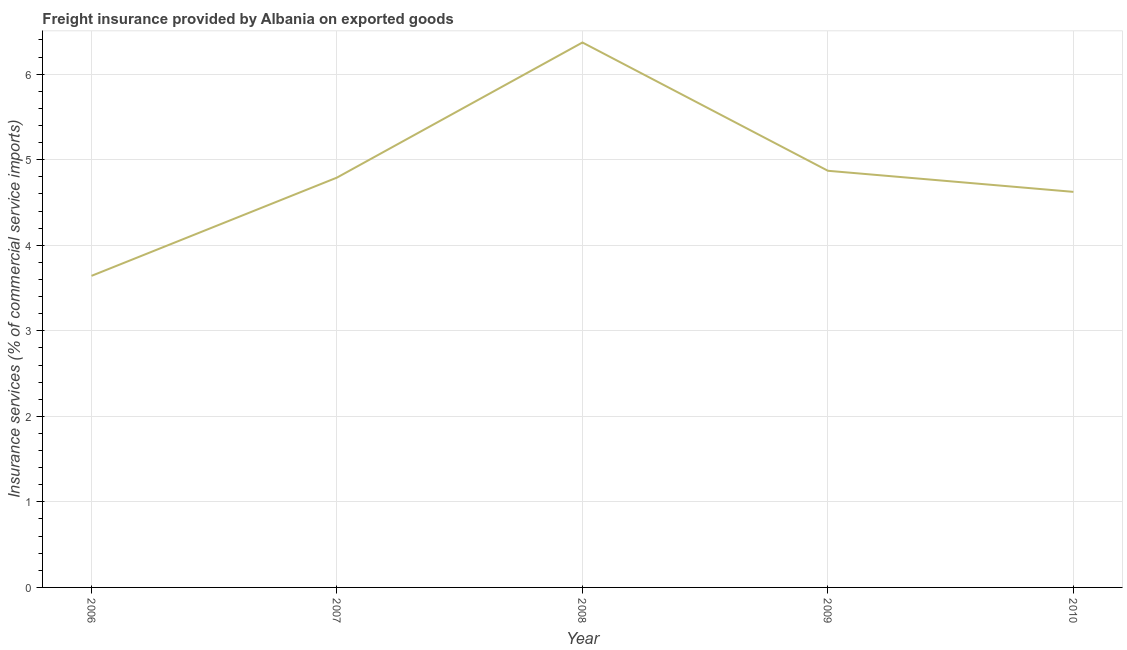What is the freight insurance in 2009?
Provide a short and direct response. 4.87. Across all years, what is the maximum freight insurance?
Provide a succinct answer. 6.37. Across all years, what is the minimum freight insurance?
Provide a succinct answer. 3.64. In which year was the freight insurance maximum?
Your answer should be compact. 2008. What is the sum of the freight insurance?
Provide a succinct answer. 24.3. What is the difference between the freight insurance in 2008 and 2010?
Make the answer very short. 1.75. What is the average freight insurance per year?
Your response must be concise. 4.86. What is the median freight insurance?
Provide a succinct answer. 4.79. In how many years, is the freight insurance greater than 4.4 %?
Make the answer very short. 4. What is the ratio of the freight insurance in 2006 to that in 2007?
Your answer should be very brief. 0.76. Is the difference between the freight insurance in 2006 and 2007 greater than the difference between any two years?
Offer a terse response. No. What is the difference between the highest and the second highest freight insurance?
Your answer should be very brief. 1.5. Is the sum of the freight insurance in 2007 and 2009 greater than the maximum freight insurance across all years?
Offer a terse response. Yes. What is the difference between the highest and the lowest freight insurance?
Make the answer very short. 2.73. In how many years, is the freight insurance greater than the average freight insurance taken over all years?
Make the answer very short. 2. Does the freight insurance monotonically increase over the years?
Offer a very short reply. No. How many lines are there?
Keep it short and to the point. 1. What is the difference between two consecutive major ticks on the Y-axis?
Your response must be concise. 1. Are the values on the major ticks of Y-axis written in scientific E-notation?
Give a very brief answer. No. Does the graph contain any zero values?
Offer a terse response. No. What is the title of the graph?
Provide a succinct answer. Freight insurance provided by Albania on exported goods . What is the label or title of the Y-axis?
Give a very brief answer. Insurance services (% of commercial service imports). What is the Insurance services (% of commercial service imports) of 2006?
Ensure brevity in your answer.  3.64. What is the Insurance services (% of commercial service imports) of 2007?
Your response must be concise. 4.79. What is the Insurance services (% of commercial service imports) in 2008?
Give a very brief answer. 6.37. What is the Insurance services (% of commercial service imports) of 2009?
Ensure brevity in your answer.  4.87. What is the Insurance services (% of commercial service imports) in 2010?
Give a very brief answer. 4.62. What is the difference between the Insurance services (% of commercial service imports) in 2006 and 2007?
Offer a very short reply. -1.15. What is the difference between the Insurance services (% of commercial service imports) in 2006 and 2008?
Give a very brief answer. -2.73. What is the difference between the Insurance services (% of commercial service imports) in 2006 and 2009?
Offer a terse response. -1.23. What is the difference between the Insurance services (% of commercial service imports) in 2006 and 2010?
Keep it short and to the point. -0.98. What is the difference between the Insurance services (% of commercial service imports) in 2007 and 2008?
Provide a short and direct response. -1.58. What is the difference between the Insurance services (% of commercial service imports) in 2007 and 2009?
Your answer should be compact. -0.08. What is the difference between the Insurance services (% of commercial service imports) in 2007 and 2010?
Give a very brief answer. 0.17. What is the difference between the Insurance services (% of commercial service imports) in 2008 and 2009?
Your response must be concise. 1.5. What is the difference between the Insurance services (% of commercial service imports) in 2008 and 2010?
Give a very brief answer. 1.75. What is the difference between the Insurance services (% of commercial service imports) in 2009 and 2010?
Offer a terse response. 0.25. What is the ratio of the Insurance services (% of commercial service imports) in 2006 to that in 2007?
Ensure brevity in your answer.  0.76. What is the ratio of the Insurance services (% of commercial service imports) in 2006 to that in 2008?
Offer a very short reply. 0.57. What is the ratio of the Insurance services (% of commercial service imports) in 2006 to that in 2009?
Provide a succinct answer. 0.75. What is the ratio of the Insurance services (% of commercial service imports) in 2006 to that in 2010?
Your answer should be compact. 0.79. What is the ratio of the Insurance services (% of commercial service imports) in 2007 to that in 2008?
Your response must be concise. 0.75. What is the ratio of the Insurance services (% of commercial service imports) in 2007 to that in 2009?
Provide a short and direct response. 0.98. What is the ratio of the Insurance services (% of commercial service imports) in 2007 to that in 2010?
Keep it short and to the point. 1.04. What is the ratio of the Insurance services (% of commercial service imports) in 2008 to that in 2009?
Offer a terse response. 1.31. What is the ratio of the Insurance services (% of commercial service imports) in 2008 to that in 2010?
Your answer should be very brief. 1.38. What is the ratio of the Insurance services (% of commercial service imports) in 2009 to that in 2010?
Ensure brevity in your answer.  1.05. 